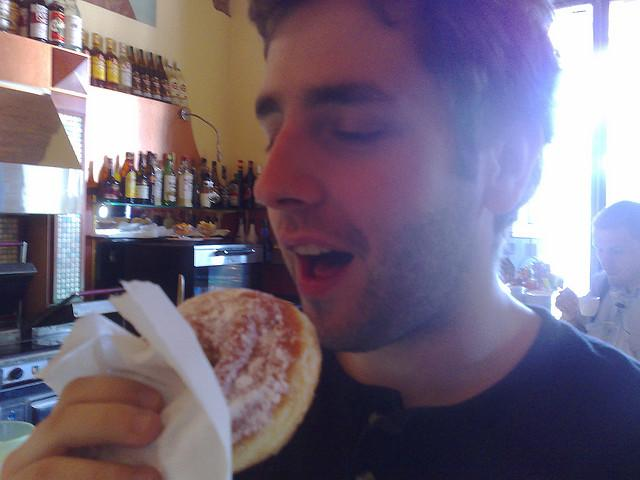How was the item prepared that is about to be bitten? Please explain your reasoning. deep fried. The item was fried. 